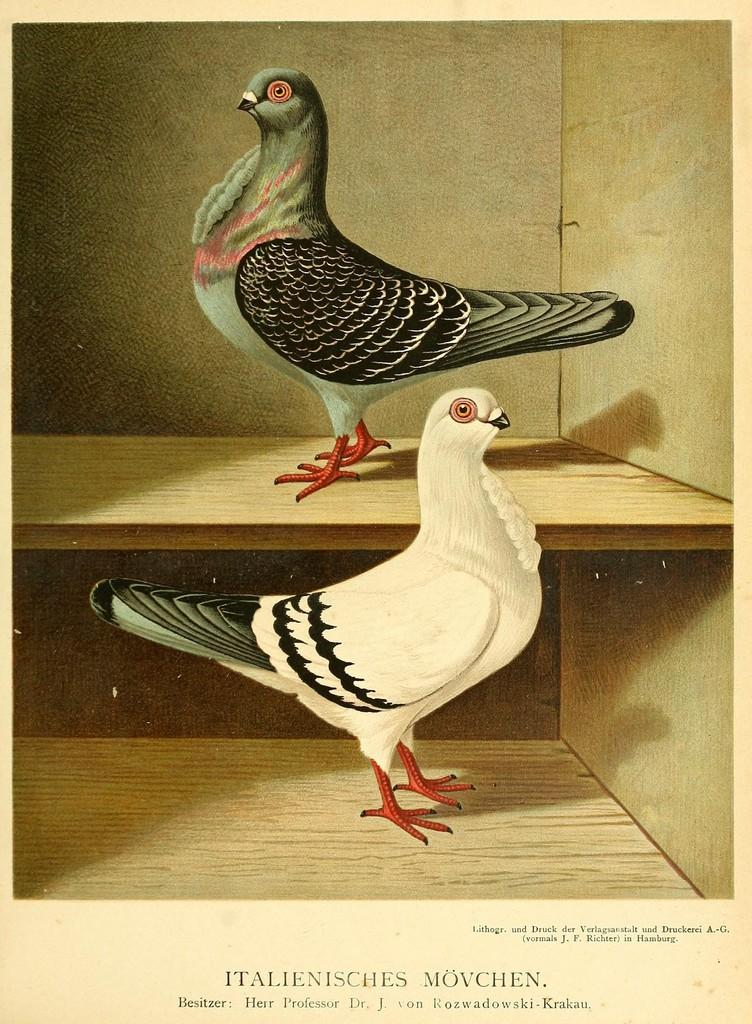What is the main object in the image? There is a wooden rack in the image. What is on the wooden rack? There are two birds on the wooden rack. Can you describe the appearance of the birds? The birds have black, green, pink, white, and red colors. What is written at the bottom of the image? There are words written at the bottom of the image. What type of star can be seen bursting in the image? There is no star or bursting event present in the image. What crime is being committed by the birds in the image? There is no crime being committed by the birds in the image; they are simply perched on the wooden rack. 